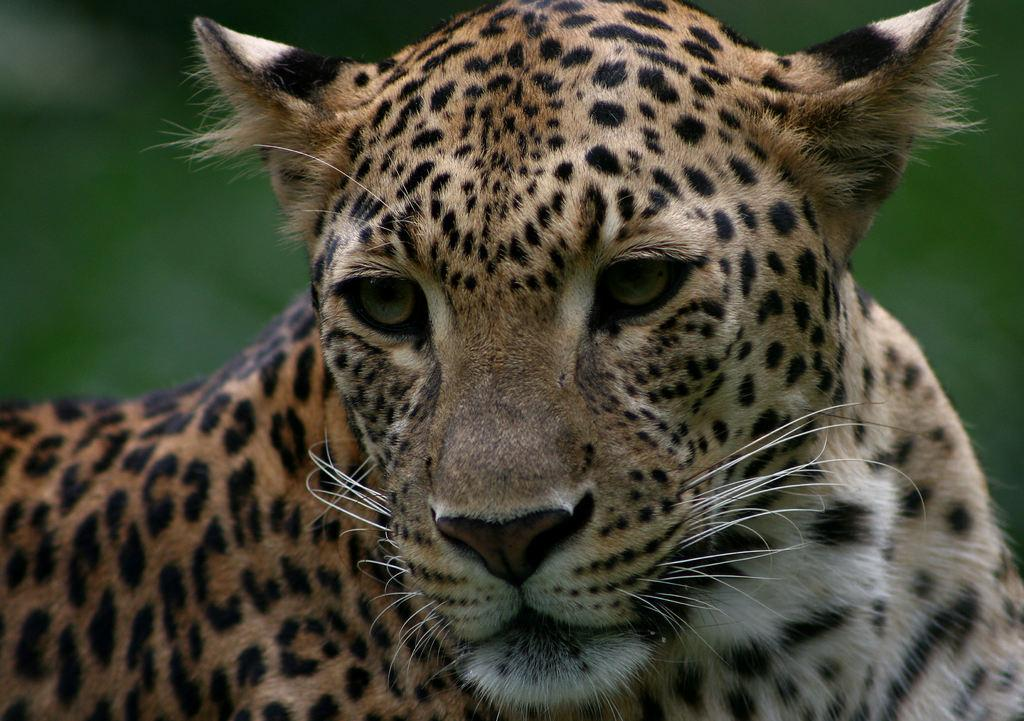What type of animal is in the image? There is a cheetah in the image. What type of street design can be seen in the image? There is no street or design present in the image; it features a cheetah. How many planes are visible in the image? There are no planes visible in the image; it features a cheetah. 